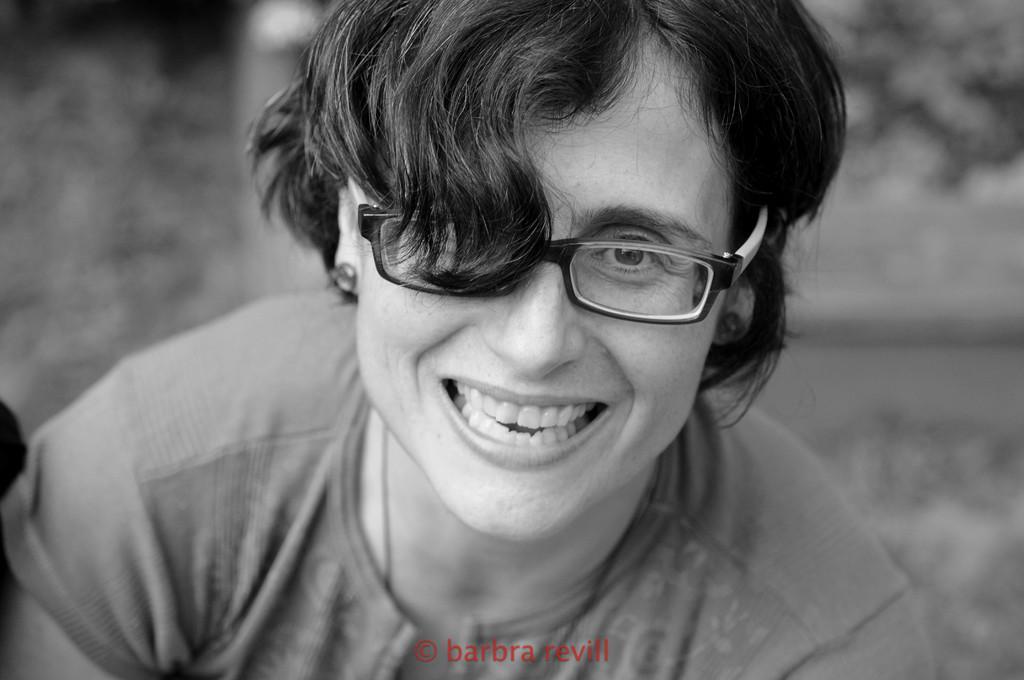Could you give a brief overview of what you see in this image? In this picture there is person sitting and smiling. At the back the image is blurry. At the bottom there is a text. 